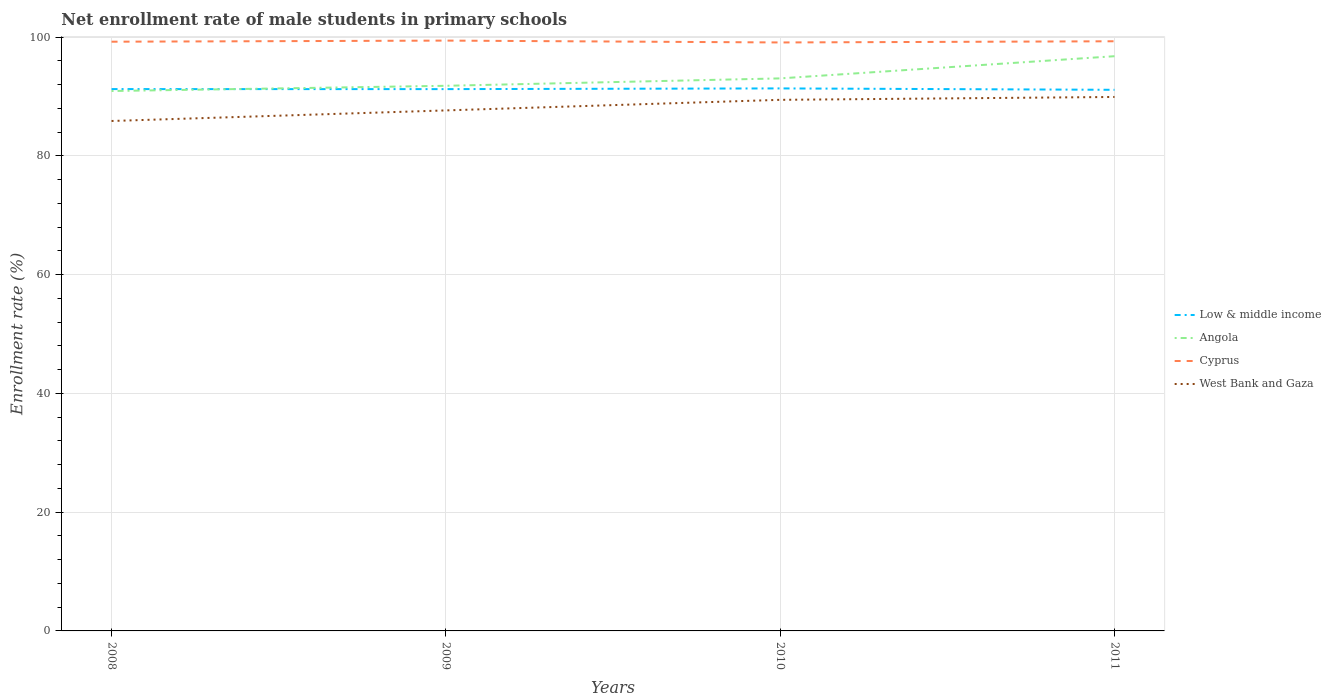Does the line corresponding to Cyprus intersect with the line corresponding to Low & middle income?
Provide a succinct answer. No. Is the number of lines equal to the number of legend labels?
Your response must be concise. Yes. Across all years, what is the maximum net enrollment rate of male students in primary schools in Cyprus?
Make the answer very short. 99.12. In which year was the net enrollment rate of male students in primary schools in West Bank and Gaza maximum?
Make the answer very short. 2008. What is the total net enrollment rate of male students in primary schools in West Bank and Gaza in the graph?
Provide a succinct answer. -4.05. What is the difference between the highest and the second highest net enrollment rate of male students in primary schools in Cyprus?
Provide a short and direct response. 0.31. How many lines are there?
Give a very brief answer. 4. How many years are there in the graph?
Provide a short and direct response. 4. Where does the legend appear in the graph?
Give a very brief answer. Center right. How are the legend labels stacked?
Provide a succinct answer. Vertical. What is the title of the graph?
Make the answer very short. Net enrollment rate of male students in primary schools. What is the label or title of the Y-axis?
Your response must be concise. Enrollment rate (%). What is the Enrollment rate (%) in Low & middle income in 2008?
Offer a terse response. 91.26. What is the Enrollment rate (%) of Angola in 2008?
Give a very brief answer. 90.94. What is the Enrollment rate (%) in Cyprus in 2008?
Your answer should be very brief. 99.24. What is the Enrollment rate (%) of West Bank and Gaza in 2008?
Offer a very short reply. 85.89. What is the Enrollment rate (%) in Low & middle income in 2009?
Offer a terse response. 91.26. What is the Enrollment rate (%) of Angola in 2009?
Give a very brief answer. 91.82. What is the Enrollment rate (%) in Cyprus in 2009?
Keep it short and to the point. 99.43. What is the Enrollment rate (%) in West Bank and Gaza in 2009?
Keep it short and to the point. 87.67. What is the Enrollment rate (%) in Low & middle income in 2010?
Your answer should be compact. 91.38. What is the Enrollment rate (%) in Angola in 2010?
Make the answer very short. 93.06. What is the Enrollment rate (%) in Cyprus in 2010?
Your answer should be compact. 99.12. What is the Enrollment rate (%) of West Bank and Gaza in 2010?
Provide a succinct answer. 89.45. What is the Enrollment rate (%) in Low & middle income in 2011?
Your answer should be very brief. 91.14. What is the Enrollment rate (%) in Angola in 2011?
Offer a very short reply. 96.8. What is the Enrollment rate (%) in Cyprus in 2011?
Provide a short and direct response. 99.32. What is the Enrollment rate (%) of West Bank and Gaza in 2011?
Ensure brevity in your answer.  89.94. Across all years, what is the maximum Enrollment rate (%) of Low & middle income?
Provide a short and direct response. 91.38. Across all years, what is the maximum Enrollment rate (%) in Angola?
Provide a succinct answer. 96.8. Across all years, what is the maximum Enrollment rate (%) in Cyprus?
Provide a succinct answer. 99.43. Across all years, what is the maximum Enrollment rate (%) in West Bank and Gaza?
Your answer should be compact. 89.94. Across all years, what is the minimum Enrollment rate (%) in Low & middle income?
Keep it short and to the point. 91.14. Across all years, what is the minimum Enrollment rate (%) of Angola?
Your answer should be very brief. 90.94. Across all years, what is the minimum Enrollment rate (%) of Cyprus?
Keep it short and to the point. 99.12. Across all years, what is the minimum Enrollment rate (%) of West Bank and Gaza?
Provide a succinct answer. 85.89. What is the total Enrollment rate (%) in Low & middle income in the graph?
Offer a very short reply. 365.03. What is the total Enrollment rate (%) of Angola in the graph?
Offer a terse response. 372.62. What is the total Enrollment rate (%) of Cyprus in the graph?
Provide a succinct answer. 397.1. What is the total Enrollment rate (%) of West Bank and Gaza in the graph?
Give a very brief answer. 352.95. What is the difference between the Enrollment rate (%) in Low & middle income in 2008 and that in 2009?
Your answer should be compact. 0.01. What is the difference between the Enrollment rate (%) of Angola in 2008 and that in 2009?
Keep it short and to the point. -0.88. What is the difference between the Enrollment rate (%) of Cyprus in 2008 and that in 2009?
Provide a succinct answer. -0.19. What is the difference between the Enrollment rate (%) of West Bank and Gaza in 2008 and that in 2009?
Keep it short and to the point. -1.78. What is the difference between the Enrollment rate (%) of Low & middle income in 2008 and that in 2010?
Your answer should be compact. -0.11. What is the difference between the Enrollment rate (%) of Angola in 2008 and that in 2010?
Keep it short and to the point. -2.13. What is the difference between the Enrollment rate (%) of Cyprus in 2008 and that in 2010?
Ensure brevity in your answer.  0.13. What is the difference between the Enrollment rate (%) of West Bank and Gaza in 2008 and that in 2010?
Ensure brevity in your answer.  -3.56. What is the difference between the Enrollment rate (%) of Low & middle income in 2008 and that in 2011?
Keep it short and to the point. 0.12. What is the difference between the Enrollment rate (%) of Angola in 2008 and that in 2011?
Your response must be concise. -5.87. What is the difference between the Enrollment rate (%) in Cyprus in 2008 and that in 2011?
Offer a terse response. -0.07. What is the difference between the Enrollment rate (%) of West Bank and Gaza in 2008 and that in 2011?
Make the answer very short. -4.05. What is the difference between the Enrollment rate (%) in Low & middle income in 2009 and that in 2010?
Provide a succinct answer. -0.12. What is the difference between the Enrollment rate (%) of Angola in 2009 and that in 2010?
Keep it short and to the point. -1.25. What is the difference between the Enrollment rate (%) in Cyprus in 2009 and that in 2010?
Your answer should be compact. 0.31. What is the difference between the Enrollment rate (%) in West Bank and Gaza in 2009 and that in 2010?
Provide a short and direct response. -1.78. What is the difference between the Enrollment rate (%) in Low & middle income in 2009 and that in 2011?
Your answer should be compact. 0.12. What is the difference between the Enrollment rate (%) of Angola in 2009 and that in 2011?
Offer a terse response. -4.98. What is the difference between the Enrollment rate (%) of Cyprus in 2009 and that in 2011?
Offer a very short reply. 0.11. What is the difference between the Enrollment rate (%) in West Bank and Gaza in 2009 and that in 2011?
Your response must be concise. -2.27. What is the difference between the Enrollment rate (%) in Low & middle income in 2010 and that in 2011?
Your answer should be compact. 0.24. What is the difference between the Enrollment rate (%) in Angola in 2010 and that in 2011?
Your answer should be very brief. -3.74. What is the difference between the Enrollment rate (%) of Cyprus in 2010 and that in 2011?
Offer a very short reply. -0.2. What is the difference between the Enrollment rate (%) of West Bank and Gaza in 2010 and that in 2011?
Provide a short and direct response. -0.48. What is the difference between the Enrollment rate (%) in Low & middle income in 2008 and the Enrollment rate (%) in Angola in 2009?
Your answer should be compact. -0.55. What is the difference between the Enrollment rate (%) of Low & middle income in 2008 and the Enrollment rate (%) of Cyprus in 2009?
Offer a very short reply. -8.17. What is the difference between the Enrollment rate (%) of Low & middle income in 2008 and the Enrollment rate (%) of West Bank and Gaza in 2009?
Offer a terse response. 3.59. What is the difference between the Enrollment rate (%) of Angola in 2008 and the Enrollment rate (%) of Cyprus in 2009?
Make the answer very short. -8.49. What is the difference between the Enrollment rate (%) of Angola in 2008 and the Enrollment rate (%) of West Bank and Gaza in 2009?
Offer a terse response. 3.26. What is the difference between the Enrollment rate (%) in Cyprus in 2008 and the Enrollment rate (%) in West Bank and Gaza in 2009?
Make the answer very short. 11.57. What is the difference between the Enrollment rate (%) in Low & middle income in 2008 and the Enrollment rate (%) in Angola in 2010?
Your answer should be very brief. -1.8. What is the difference between the Enrollment rate (%) in Low & middle income in 2008 and the Enrollment rate (%) in Cyprus in 2010?
Provide a succinct answer. -7.85. What is the difference between the Enrollment rate (%) of Low & middle income in 2008 and the Enrollment rate (%) of West Bank and Gaza in 2010?
Your response must be concise. 1.81. What is the difference between the Enrollment rate (%) in Angola in 2008 and the Enrollment rate (%) in Cyprus in 2010?
Your answer should be compact. -8.18. What is the difference between the Enrollment rate (%) of Angola in 2008 and the Enrollment rate (%) of West Bank and Gaza in 2010?
Your answer should be very brief. 1.48. What is the difference between the Enrollment rate (%) in Cyprus in 2008 and the Enrollment rate (%) in West Bank and Gaza in 2010?
Ensure brevity in your answer.  9.79. What is the difference between the Enrollment rate (%) of Low & middle income in 2008 and the Enrollment rate (%) of Angola in 2011?
Ensure brevity in your answer.  -5.54. What is the difference between the Enrollment rate (%) in Low & middle income in 2008 and the Enrollment rate (%) in Cyprus in 2011?
Your answer should be very brief. -8.05. What is the difference between the Enrollment rate (%) of Low & middle income in 2008 and the Enrollment rate (%) of West Bank and Gaza in 2011?
Your answer should be compact. 1.33. What is the difference between the Enrollment rate (%) in Angola in 2008 and the Enrollment rate (%) in Cyprus in 2011?
Offer a very short reply. -8.38. What is the difference between the Enrollment rate (%) in Cyprus in 2008 and the Enrollment rate (%) in West Bank and Gaza in 2011?
Offer a very short reply. 9.31. What is the difference between the Enrollment rate (%) of Low & middle income in 2009 and the Enrollment rate (%) of Angola in 2010?
Make the answer very short. -1.81. What is the difference between the Enrollment rate (%) in Low & middle income in 2009 and the Enrollment rate (%) in Cyprus in 2010?
Your answer should be very brief. -7.86. What is the difference between the Enrollment rate (%) in Low & middle income in 2009 and the Enrollment rate (%) in West Bank and Gaza in 2010?
Make the answer very short. 1.8. What is the difference between the Enrollment rate (%) of Angola in 2009 and the Enrollment rate (%) of Cyprus in 2010?
Provide a short and direct response. -7.3. What is the difference between the Enrollment rate (%) of Angola in 2009 and the Enrollment rate (%) of West Bank and Gaza in 2010?
Your response must be concise. 2.37. What is the difference between the Enrollment rate (%) in Cyprus in 2009 and the Enrollment rate (%) in West Bank and Gaza in 2010?
Your answer should be compact. 9.98. What is the difference between the Enrollment rate (%) of Low & middle income in 2009 and the Enrollment rate (%) of Angola in 2011?
Your response must be concise. -5.54. What is the difference between the Enrollment rate (%) of Low & middle income in 2009 and the Enrollment rate (%) of Cyprus in 2011?
Offer a terse response. -8.06. What is the difference between the Enrollment rate (%) of Low & middle income in 2009 and the Enrollment rate (%) of West Bank and Gaza in 2011?
Give a very brief answer. 1.32. What is the difference between the Enrollment rate (%) in Angola in 2009 and the Enrollment rate (%) in Cyprus in 2011?
Your answer should be compact. -7.5. What is the difference between the Enrollment rate (%) of Angola in 2009 and the Enrollment rate (%) of West Bank and Gaza in 2011?
Provide a short and direct response. 1.88. What is the difference between the Enrollment rate (%) of Cyprus in 2009 and the Enrollment rate (%) of West Bank and Gaza in 2011?
Provide a succinct answer. 9.49. What is the difference between the Enrollment rate (%) of Low & middle income in 2010 and the Enrollment rate (%) of Angola in 2011?
Provide a short and direct response. -5.42. What is the difference between the Enrollment rate (%) in Low & middle income in 2010 and the Enrollment rate (%) in Cyprus in 2011?
Your response must be concise. -7.94. What is the difference between the Enrollment rate (%) in Low & middle income in 2010 and the Enrollment rate (%) in West Bank and Gaza in 2011?
Keep it short and to the point. 1.44. What is the difference between the Enrollment rate (%) in Angola in 2010 and the Enrollment rate (%) in Cyprus in 2011?
Give a very brief answer. -6.25. What is the difference between the Enrollment rate (%) in Angola in 2010 and the Enrollment rate (%) in West Bank and Gaza in 2011?
Make the answer very short. 3.13. What is the difference between the Enrollment rate (%) of Cyprus in 2010 and the Enrollment rate (%) of West Bank and Gaza in 2011?
Give a very brief answer. 9.18. What is the average Enrollment rate (%) in Low & middle income per year?
Give a very brief answer. 91.26. What is the average Enrollment rate (%) of Angola per year?
Provide a short and direct response. 93.15. What is the average Enrollment rate (%) of Cyprus per year?
Your answer should be very brief. 99.28. What is the average Enrollment rate (%) of West Bank and Gaza per year?
Provide a succinct answer. 88.24. In the year 2008, what is the difference between the Enrollment rate (%) in Low & middle income and Enrollment rate (%) in Angola?
Make the answer very short. 0.33. In the year 2008, what is the difference between the Enrollment rate (%) in Low & middle income and Enrollment rate (%) in Cyprus?
Ensure brevity in your answer.  -7.98. In the year 2008, what is the difference between the Enrollment rate (%) in Low & middle income and Enrollment rate (%) in West Bank and Gaza?
Provide a succinct answer. 5.37. In the year 2008, what is the difference between the Enrollment rate (%) of Angola and Enrollment rate (%) of Cyprus?
Your answer should be very brief. -8.31. In the year 2008, what is the difference between the Enrollment rate (%) in Angola and Enrollment rate (%) in West Bank and Gaza?
Your answer should be compact. 5.05. In the year 2008, what is the difference between the Enrollment rate (%) in Cyprus and Enrollment rate (%) in West Bank and Gaza?
Keep it short and to the point. 13.35. In the year 2009, what is the difference between the Enrollment rate (%) in Low & middle income and Enrollment rate (%) in Angola?
Your response must be concise. -0.56. In the year 2009, what is the difference between the Enrollment rate (%) in Low & middle income and Enrollment rate (%) in Cyprus?
Your answer should be compact. -8.17. In the year 2009, what is the difference between the Enrollment rate (%) of Low & middle income and Enrollment rate (%) of West Bank and Gaza?
Offer a terse response. 3.59. In the year 2009, what is the difference between the Enrollment rate (%) of Angola and Enrollment rate (%) of Cyprus?
Your response must be concise. -7.61. In the year 2009, what is the difference between the Enrollment rate (%) in Angola and Enrollment rate (%) in West Bank and Gaza?
Provide a short and direct response. 4.15. In the year 2009, what is the difference between the Enrollment rate (%) in Cyprus and Enrollment rate (%) in West Bank and Gaza?
Your answer should be compact. 11.76. In the year 2010, what is the difference between the Enrollment rate (%) of Low & middle income and Enrollment rate (%) of Angola?
Provide a short and direct response. -1.69. In the year 2010, what is the difference between the Enrollment rate (%) in Low & middle income and Enrollment rate (%) in Cyprus?
Ensure brevity in your answer.  -7.74. In the year 2010, what is the difference between the Enrollment rate (%) of Low & middle income and Enrollment rate (%) of West Bank and Gaza?
Offer a very short reply. 1.92. In the year 2010, what is the difference between the Enrollment rate (%) of Angola and Enrollment rate (%) of Cyprus?
Provide a short and direct response. -6.05. In the year 2010, what is the difference between the Enrollment rate (%) of Angola and Enrollment rate (%) of West Bank and Gaza?
Provide a succinct answer. 3.61. In the year 2010, what is the difference between the Enrollment rate (%) in Cyprus and Enrollment rate (%) in West Bank and Gaza?
Keep it short and to the point. 9.66. In the year 2011, what is the difference between the Enrollment rate (%) in Low & middle income and Enrollment rate (%) in Angola?
Your answer should be compact. -5.66. In the year 2011, what is the difference between the Enrollment rate (%) in Low & middle income and Enrollment rate (%) in Cyprus?
Offer a very short reply. -8.18. In the year 2011, what is the difference between the Enrollment rate (%) in Low & middle income and Enrollment rate (%) in West Bank and Gaza?
Give a very brief answer. 1.2. In the year 2011, what is the difference between the Enrollment rate (%) in Angola and Enrollment rate (%) in Cyprus?
Offer a terse response. -2.51. In the year 2011, what is the difference between the Enrollment rate (%) of Angola and Enrollment rate (%) of West Bank and Gaza?
Provide a short and direct response. 6.86. In the year 2011, what is the difference between the Enrollment rate (%) of Cyprus and Enrollment rate (%) of West Bank and Gaza?
Provide a short and direct response. 9.38. What is the ratio of the Enrollment rate (%) of Angola in 2008 to that in 2009?
Your answer should be very brief. 0.99. What is the ratio of the Enrollment rate (%) in West Bank and Gaza in 2008 to that in 2009?
Your answer should be very brief. 0.98. What is the ratio of the Enrollment rate (%) in Angola in 2008 to that in 2010?
Your response must be concise. 0.98. What is the ratio of the Enrollment rate (%) of West Bank and Gaza in 2008 to that in 2010?
Provide a succinct answer. 0.96. What is the ratio of the Enrollment rate (%) of Angola in 2008 to that in 2011?
Give a very brief answer. 0.94. What is the ratio of the Enrollment rate (%) of West Bank and Gaza in 2008 to that in 2011?
Provide a succinct answer. 0.95. What is the ratio of the Enrollment rate (%) of Low & middle income in 2009 to that in 2010?
Your response must be concise. 1. What is the ratio of the Enrollment rate (%) in Angola in 2009 to that in 2010?
Give a very brief answer. 0.99. What is the ratio of the Enrollment rate (%) of Cyprus in 2009 to that in 2010?
Your answer should be very brief. 1. What is the ratio of the Enrollment rate (%) of West Bank and Gaza in 2009 to that in 2010?
Make the answer very short. 0.98. What is the ratio of the Enrollment rate (%) of Angola in 2009 to that in 2011?
Keep it short and to the point. 0.95. What is the ratio of the Enrollment rate (%) of Cyprus in 2009 to that in 2011?
Keep it short and to the point. 1. What is the ratio of the Enrollment rate (%) of West Bank and Gaza in 2009 to that in 2011?
Give a very brief answer. 0.97. What is the ratio of the Enrollment rate (%) in Angola in 2010 to that in 2011?
Make the answer very short. 0.96. What is the ratio of the Enrollment rate (%) of West Bank and Gaza in 2010 to that in 2011?
Provide a succinct answer. 0.99. What is the difference between the highest and the second highest Enrollment rate (%) of Low & middle income?
Your answer should be compact. 0.11. What is the difference between the highest and the second highest Enrollment rate (%) of Angola?
Your answer should be very brief. 3.74. What is the difference between the highest and the second highest Enrollment rate (%) in Cyprus?
Give a very brief answer. 0.11. What is the difference between the highest and the second highest Enrollment rate (%) in West Bank and Gaza?
Offer a very short reply. 0.48. What is the difference between the highest and the lowest Enrollment rate (%) in Low & middle income?
Offer a terse response. 0.24. What is the difference between the highest and the lowest Enrollment rate (%) of Angola?
Ensure brevity in your answer.  5.87. What is the difference between the highest and the lowest Enrollment rate (%) of Cyprus?
Your response must be concise. 0.31. What is the difference between the highest and the lowest Enrollment rate (%) in West Bank and Gaza?
Give a very brief answer. 4.05. 